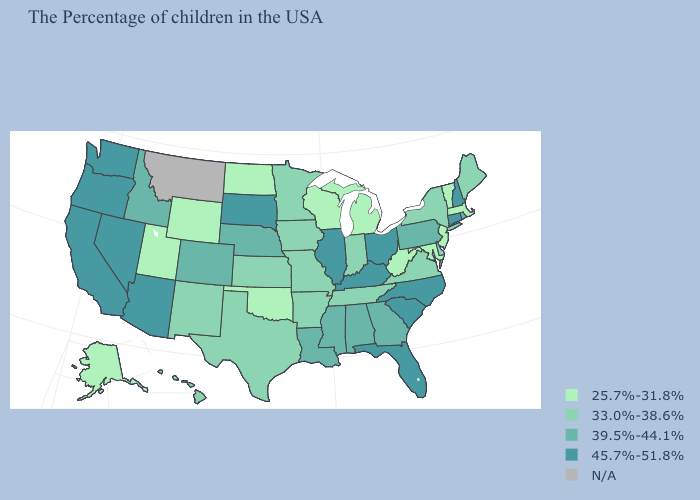Is the legend a continuous bar?
Keep it brief. No. What is the lowest value in the USA?
Short answer required. 25.7%-31.8%. What is the lowest value in the MidWest?
Quick response, please. 25.7%-31.8%. Does the first symbol in the legend represent the smallest category?
Write a very short answer. Yes. What is the value of Connecticut?
Short answer required. 45.7%-51.8%. Name the states that have a value in the range 45.7%-51.8%?
Keep it brief. New Hampshire, Connecticut, North Carolina, South Carolina, Ohio, Florida, Kentucky, Illinois, South Dakota, Arizona, Nevada, California, Washington, Oregon. Name the states that have a value in the range 39.5%-44.1%?
Write a very short answer. Rhode Island, Pennsylvania, Georgia, Alabama, Mississippi, Louisiana, Nebraska, Colorado, Idaho. Which states have the highest value in the USA?
Be succinct. New Hampshire, Connecticut, North Carolina, South Carolina, Ohio, Florida, Kentucky, Illinois, South Dakota, Arizona, Nevada, California, Washington, Oregon. What is the value of Florida?
Answer briefly. 45.7%-51.8%. What is the lowest value in states that border Iowa?
Be succinct. 25.7%-31.8%. What is the value of Nebraska?
Give a very brief answer. 39.5%-44.1%. What is the highest value in states that border Michigan?
Answer briefly. 45.7%-51.8%. Name the states that have a value in the range 39.5%-44.1%?
Short answer required. Rhode Island, Pennsylvania, Georgia, Alabama, Mississippi, Louisiana, Nebraska, Colorado, Idaho. 